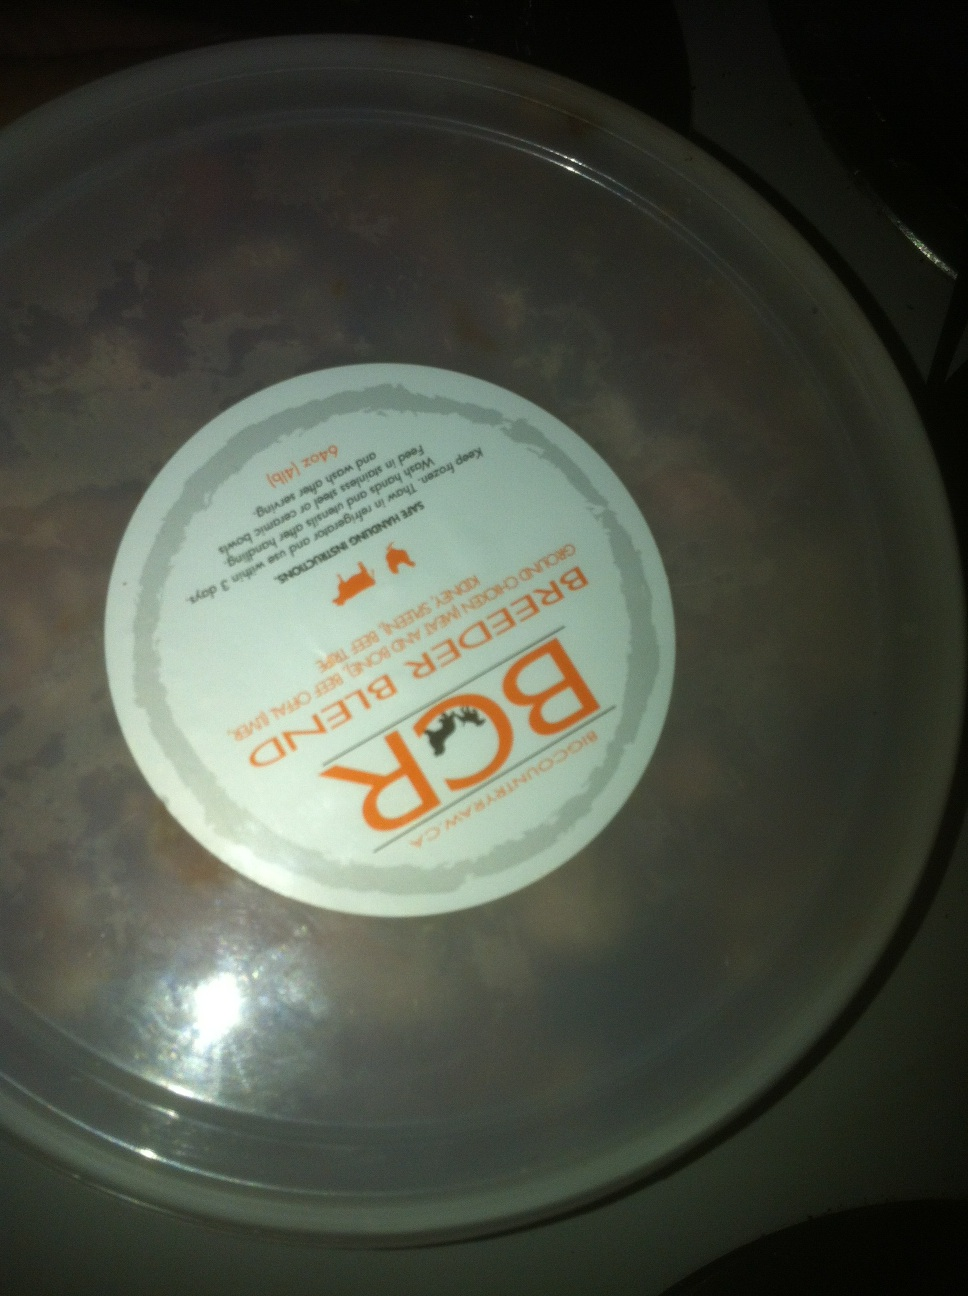Can you help me figure out what type of food this is? Certainly! Based on the label which reads 'Beef Dinner', it suggests that this item is a type of beef-based meal, possibly pet food given the graphic of what appears to be an animal on the packaging.  Is there anything else you can tell from the label on the container? The label contains additional text that may provide directions for use or nutritional information, but it's difficult to read due to the lighting and angle. I'd recommend taking a clearer photo straight on and in good lighting for more detailed information. 